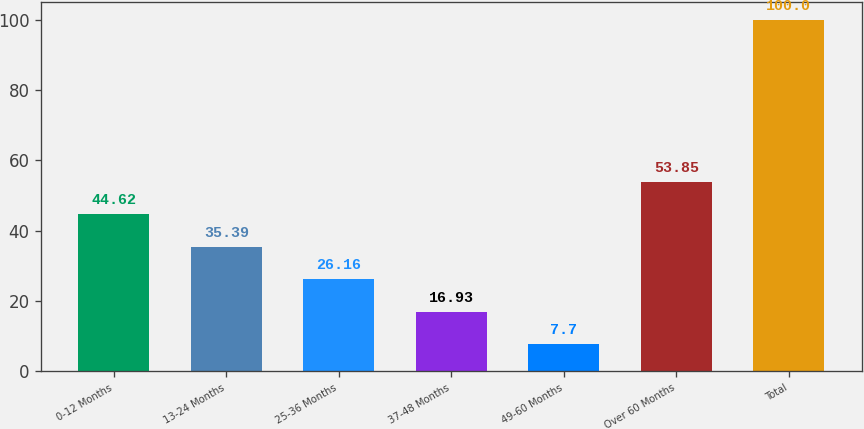<chart> <loc_0><loc_0><loc_500><loc_500><bar_chart><fcel>0-12 Months<fcel>13-24 Months<fcel>25-36 Months<fcel>37-48 Months<fcel>49-60 Months<fcel>Over 60 Months<fcel>Total<nl><fcel>44.62<fcel>35.39<fcel>26.16<fcel>16.93<fcel>7.7<fcel>53.85<fcel>100<nl></chart> 